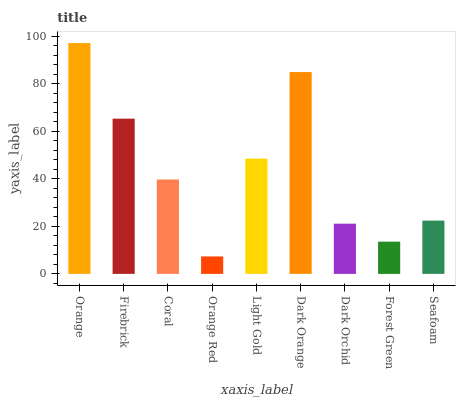Is Orange Red the minimum?
Answer yes or no. Yes. Is Orange the maximum?
Answer yes or no. Yes. Is Firebrick the minimum?
Answer yes or no. No. Is Firebrick the maximum?
Answer yes or no. No. Is Orange greater than Firebrick?
Answer yes or no. Yes. Is Firebrick less than Orange?
Answer yes or no. Yes. Is Firebrick greater than Orange?
Answer yes or no. No. Is Orange less than Firebrick?
Answer yes or no. No. Is Coral the high median?
Answer yes or no. Yes. Is Coral the low median?
Answer yes or no. Yes. Is Orange Red the high median?
Answer yes or no. No. Is Dark Orchid the low median?
Answer yes or no. No. 